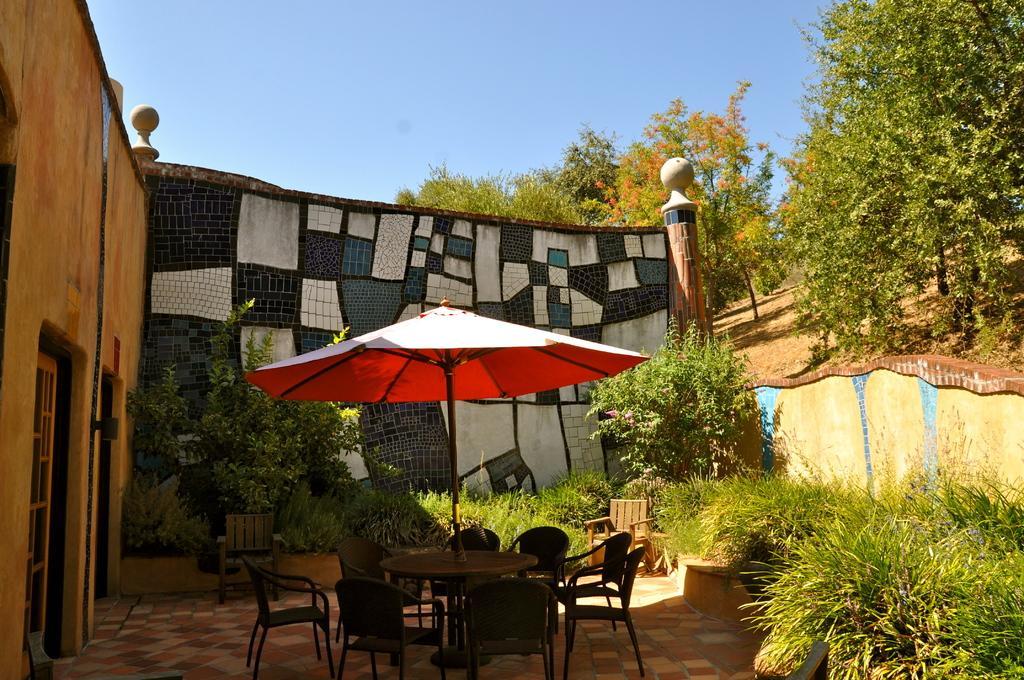Please provide a concise description of this image. In this image there is a table in the middle and there are chairs around it. Above the table there is an umbrella. In the background there is a wall on which there is some design. In front of the wall there are small plants around it. On the left side there is a wall. Under the wall there are two doors. At the top there is the sky. On the right side top there are trees. 